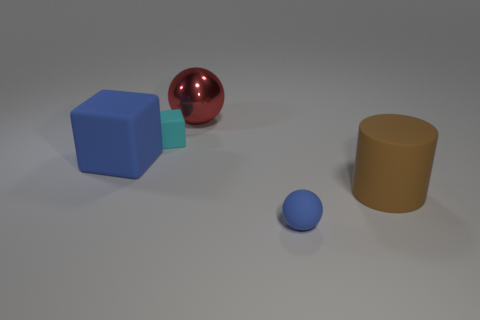Add 2 tiny rubber things. How many objects exist? 7 Subtract 1 cylinders. How many cylinders are left? 0 Subtract all blue cylinders. Subtract all purple balls. How many cylinders are left? 1 Subtract all purple blocks. How many red spheres are left? 1 Subtract all brown rubber cylinders. Subtract all small spheres. How many objects are left? 3 Add 4 cyan things. How many cyan things are left? 5 Add 5 gray metallic balls. How many gray metallic balls exist? 5 Subtract 0 purple cylinders. How many objects are left? 5 Subtract all cylinders. How many objects are left? 4 